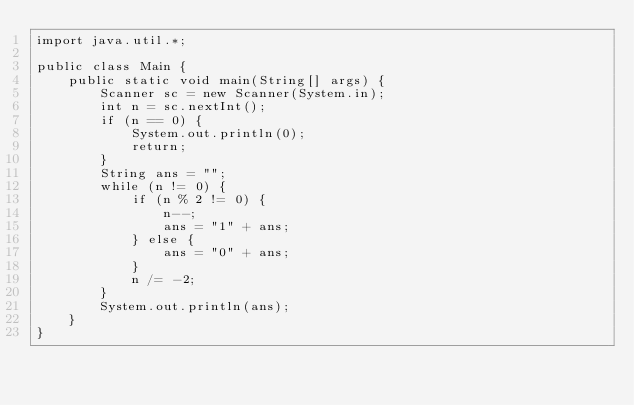<code> <loc_0><loc_0><loc_500><loc_500><_Java_>import java.util.*;

public class Main {
    public static void main(String[] args) {
        Scanner sc = new Scanner(System.in);
        int n = sc.nextInt();
        if (n == 0) {
            System.out.println(0);
            return;
        }
        String ans = "";
        while (n != 0) {
            if (n % 2 != 0) {
                n--;
                ans = "1" + ans;
            } else {
                ans = "0" + ans;
            }
            n /= -2;
        }
        System.out.println(ans);
    }
}
</code> 